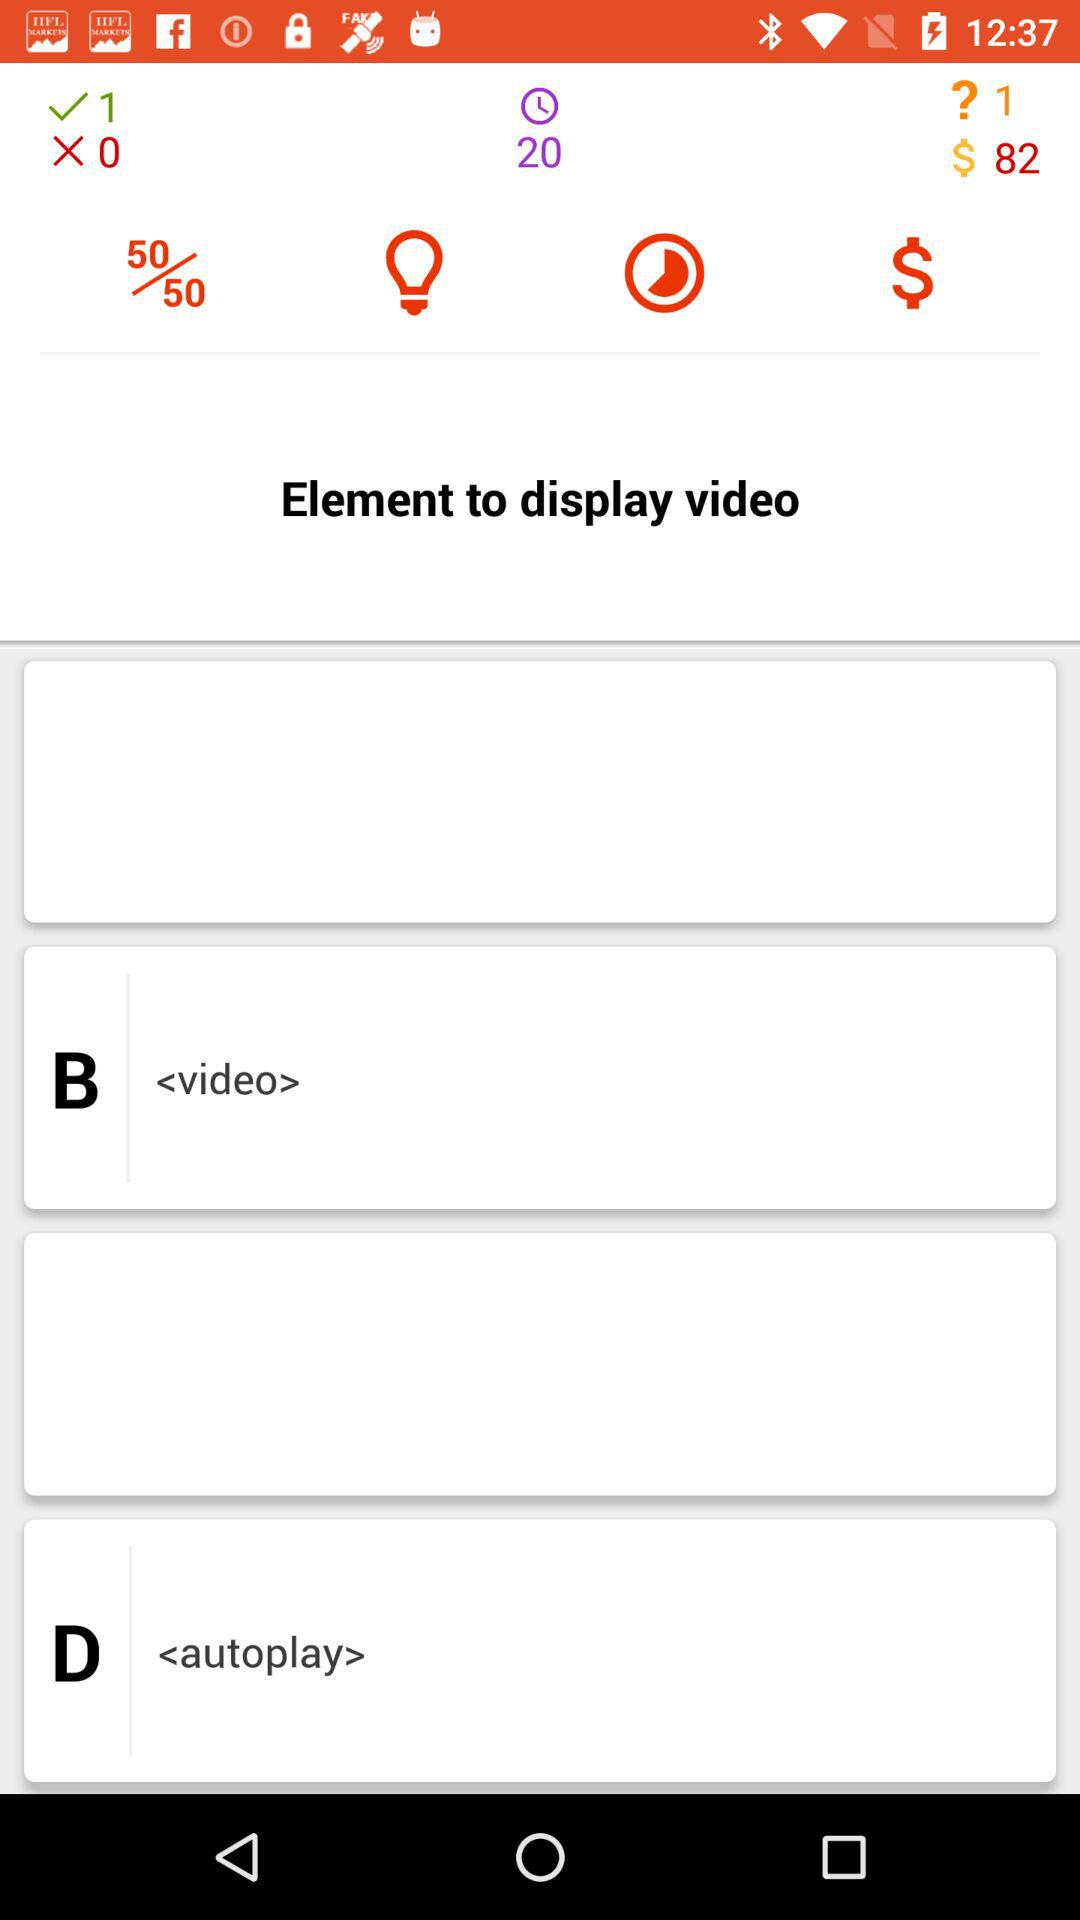How much money is earned? The earned money is $82. 